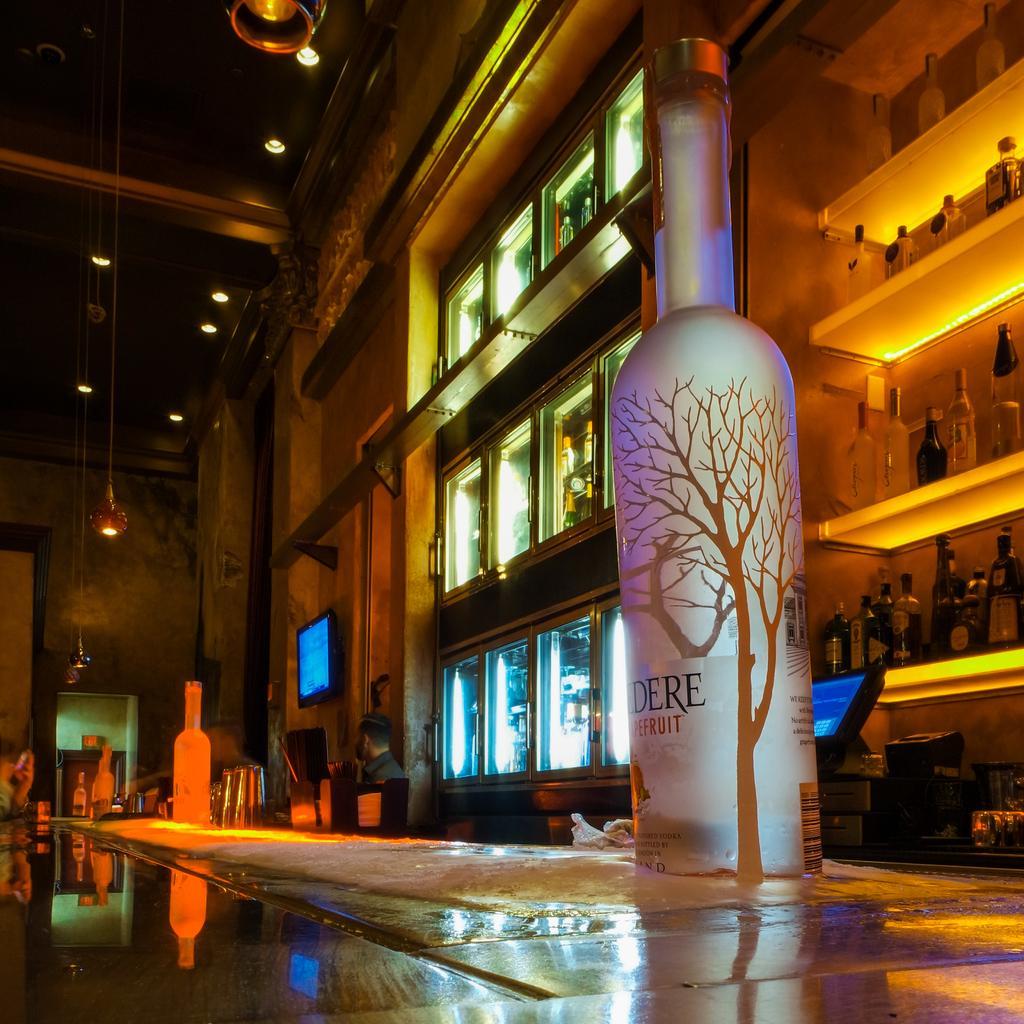Describe this image in one or two sentences. This is an inside view picture. Here we can see one man. We can see bottles arranged in a sequence manner in racks. We can see light focus here. Here on the table we can see bottles. These are televisions. At the top we can see ceiling and lights. 